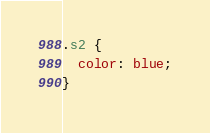<code> <loc_0><loc_0><loc_500><loc_500><_CSS_>.s2 {
  color: blue;
}
</code> 